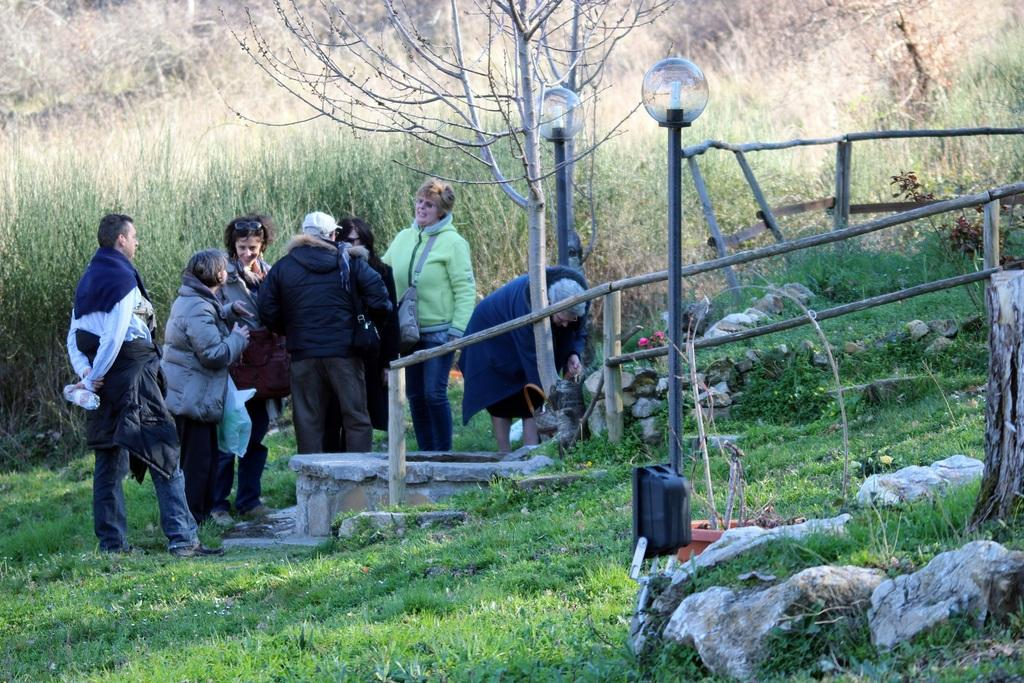Who or what is present in the image? There are people in the image. What is the surface beneath the people? The people are on a grass floor. What type of vegetation can be seen in the image? There are trees in the image. What structures are present in the image? There are poles with lamps and fencing in the image. What type of thrill can be experienced by the people in the image? There is no indication of a thrilling experience in the image; it simply shows people on a grass floor with trees, poles with lamps, and fencing. What color is the copper in the image? There is no copper present in the image. 